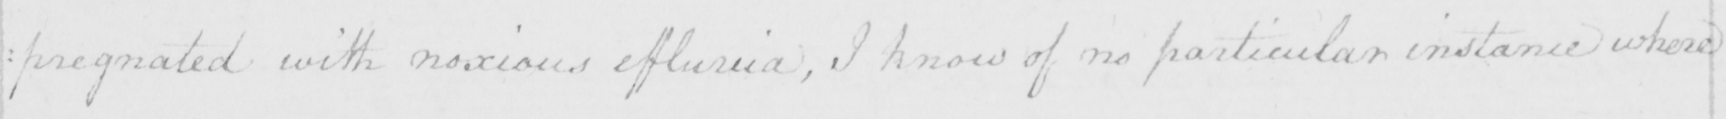What is written in this line of handwriting? : pregnated with noxious effluvia , I know of no particular instance where 